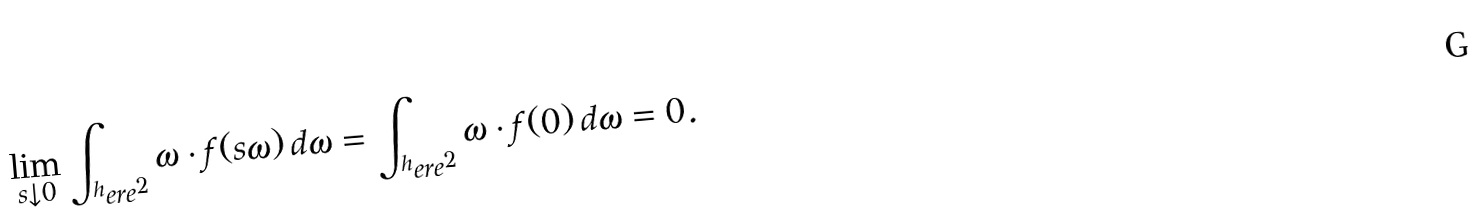<formula> <loc_0><loc_0><loc_500><loc_500>\lim _ { s \downarrow 0 } \int _ { ^ { h } e r e ^ { 2 } } \omega \cdot { f } ( s \omega ) \, d \omega = \int _ { ^ { h } e r e ^ { 2 } } \omega \cdot { f } ( 0 ) \, d \omega = 0 .</formula> 